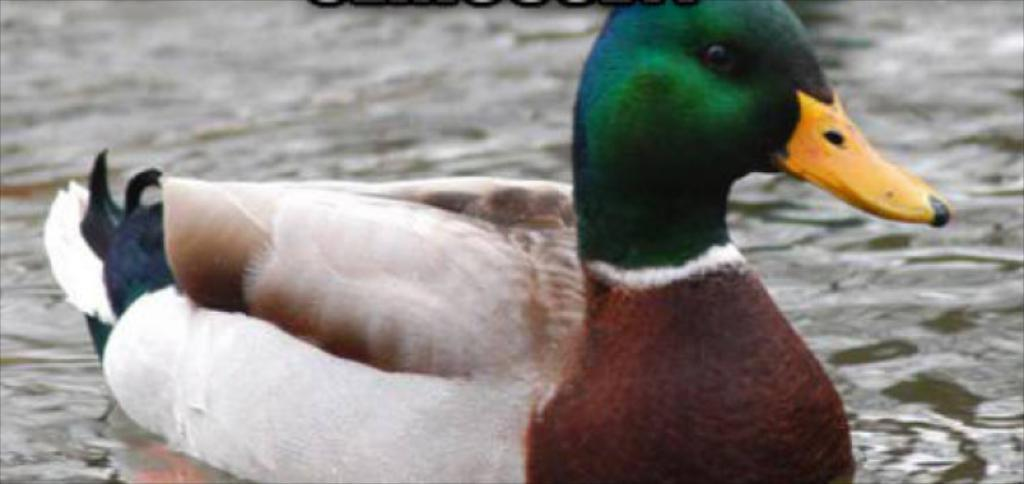What animal is present in the image? There is a duck in the image. Where is the duck located? The duck is on the surface of the water. What type of skin treatment is the duck receiving in the image? There is no indication in the image that the duck is receiving any skin treatment. 